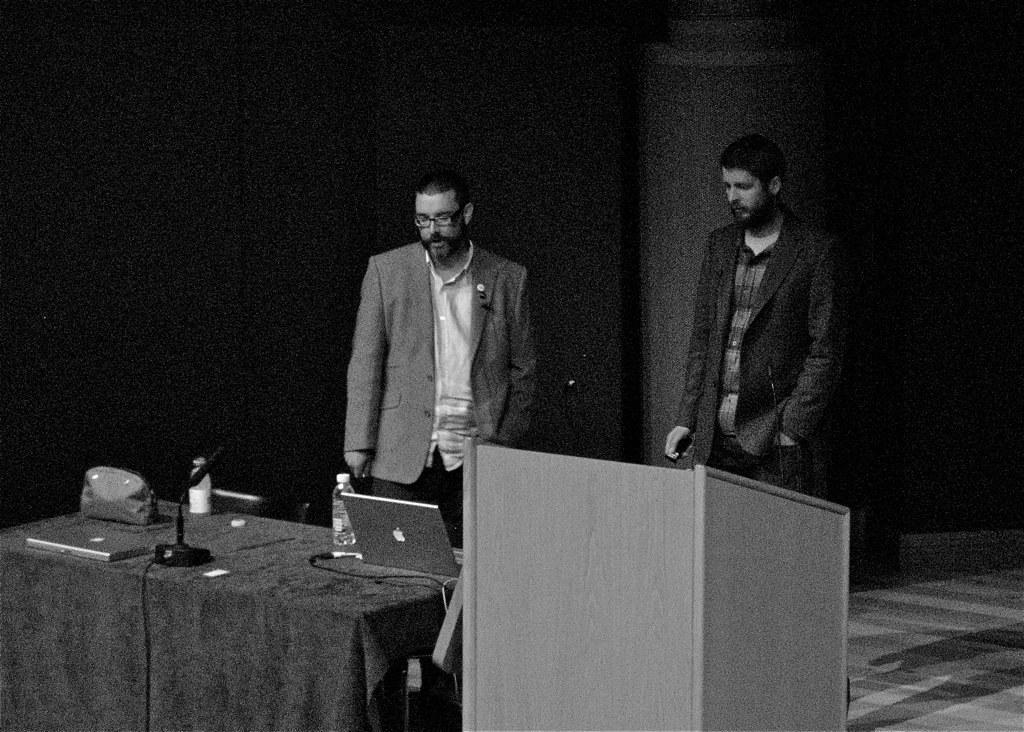Describe this image in one or two sentences. Here we can see two men standing with a table in front of them having laptops,bottle and microphone on it and beside it we can see a speech desk 